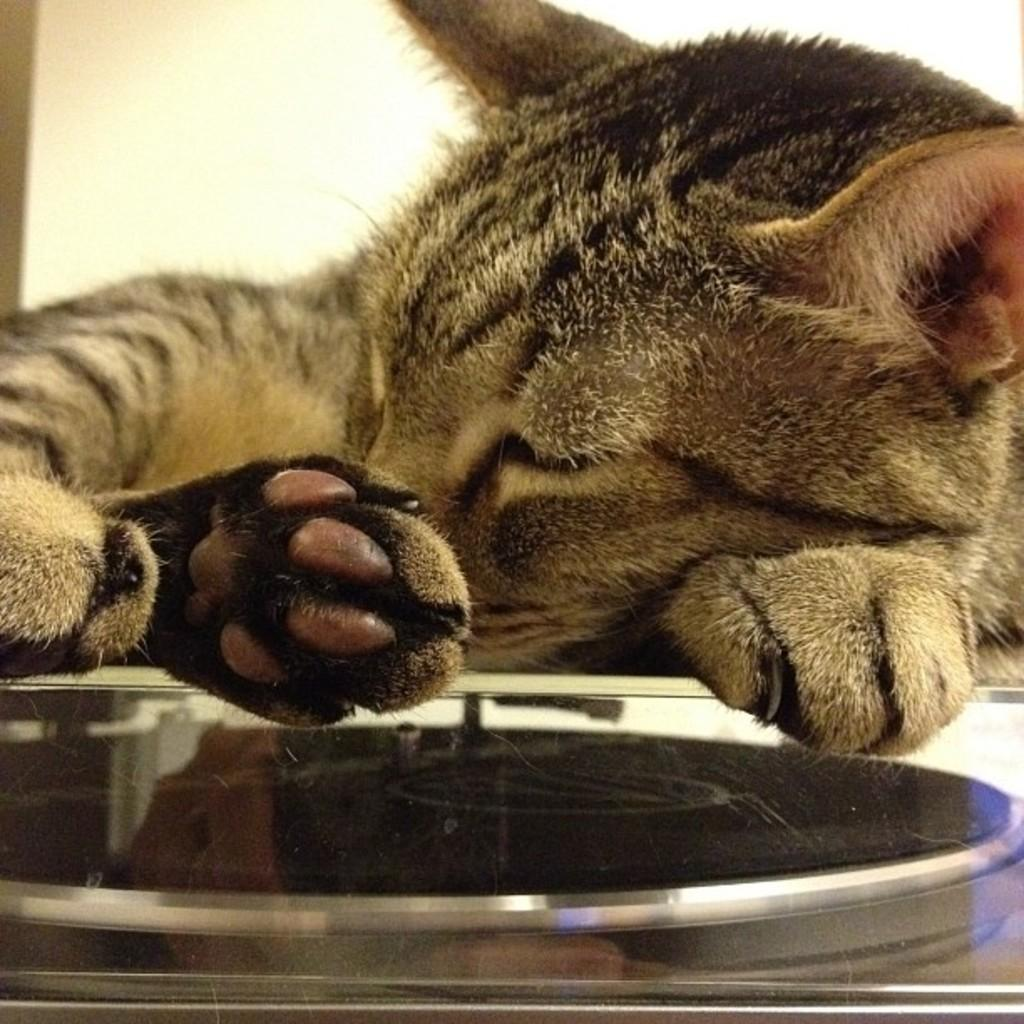What animal is present in the image? There is a cat in the image. What is the cat doing in the image? The cat is lying down. What object is in front of the cat? There is an object in front of the cat that looks like a glass. Where is the owl sitting in the image? There is no owl present in the image; it features a cat lying down. What type of food is being served in the lunchroom in the image? There is no lunchroom present in the image; it features a cat lying down and an object that looks like a glass. 